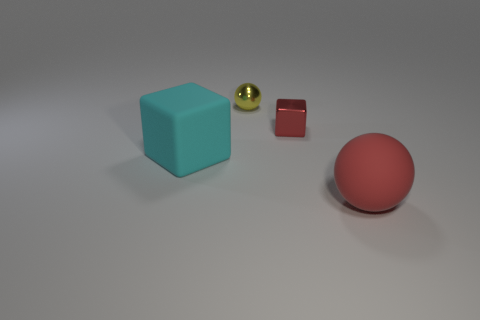Add 1 red matte blocks. How many objects exist? 5 Add 4 red cylinders. How many red cylinders exist? 4 Subtract 0 gray balls. How many objects are left? 4 Subtract all tiny blue rubber balls. Subtract all red things. How many objects are left? 2 Add 2 metallic things. How many metallic things are left? 4 